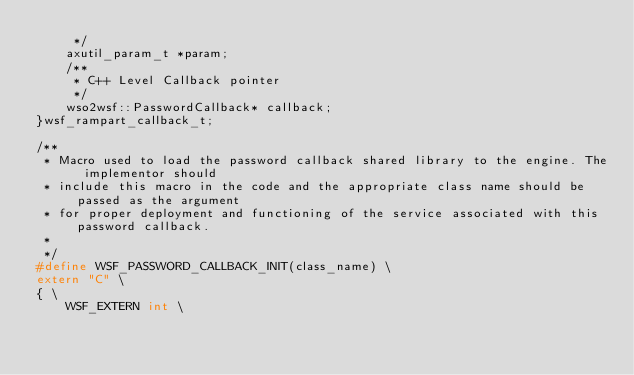<code> <loc_0><loc_0><loc_500><loc_500><_C_>     */
    axutil_param_t *param;
    /**
     * C++ Level Callback pointer
     */
    wso2wsf::PasswordCallback* callback;
}wsf_rampart_callback_t;

/**
 * Macro used to load the password callback shared library to the engine. The implementor should
 * include this macro in the code and the appropriate class name should be passed as the argument
 * for proper deployment and functioning of the service associated with this password callback.
 *
 */
#define WSF_PASSWORD_CALLBACK_INIT(class_name) \
extern "C" \
{ \
    WSF_EXTERN int \</code> 